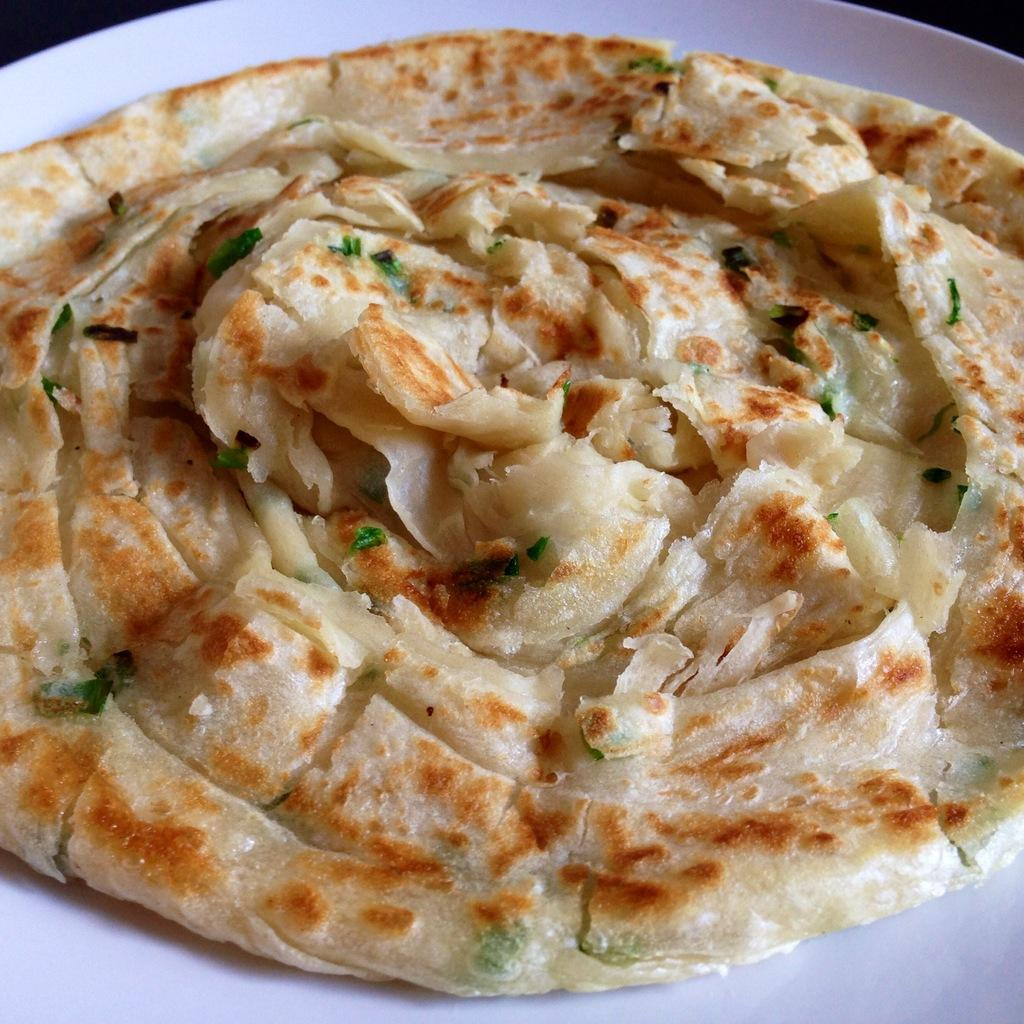What is located in the center of the image? There is a plate in the center of the image. What is on the plate? The plate contains tortilla. What type of note is attached to the tortilla on the plate? There is no note attached to the tortilla on the plate in the image. 